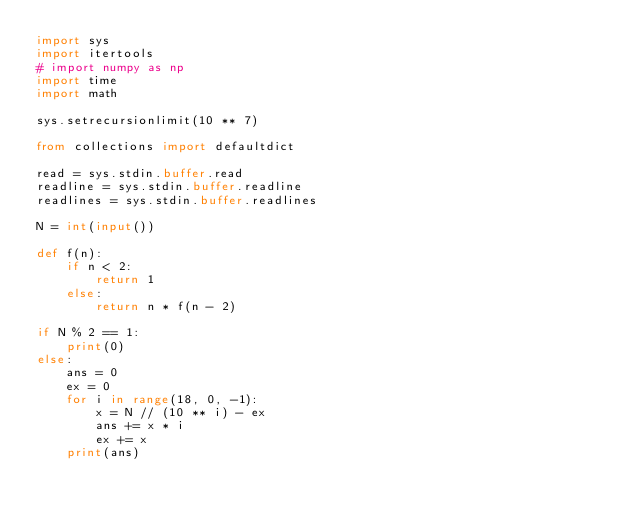<code> <loc_0><loc_0><loc_500><loc_500><_Python_>import sys
import itertools
# import numpy as np
import time
import math
 
sys.setrecursionlimit(10 ** 7)
 
from collections import defaultdict
 
read = sys.stdin.buffer.read
readline = sys.stdin.buffer.readline
readlines = sys.stdin.buffer.readlines

N = int(input())

def f(n):
    if n < 2:
        return 1
    else:
        return n * f(n - 2)

if N % 2 == 1:
    print(0)
else:
    ans = 0
    ex = 0
    for i in range(18, 0, -1):
        x = N // (10 ** i) - ex
        ans += x * i 
        ex += x
    print(ans)
</code> 